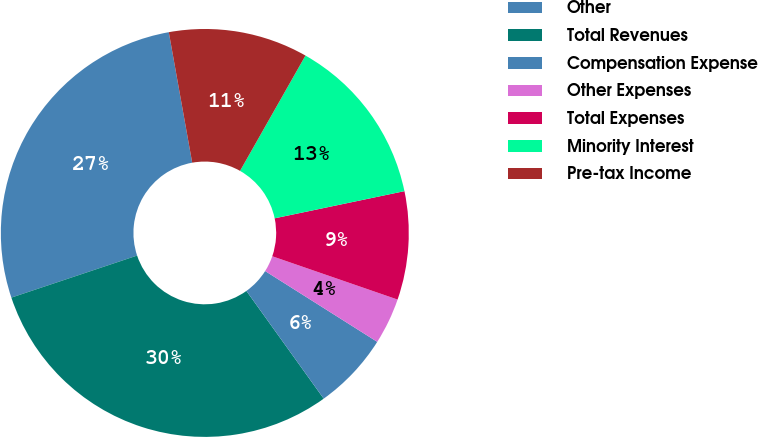Convert chart. <chart><loc_0><loc_0><loc_500><loc_500><pie_chart><fcel>Other<fcel>Total Revenues<fcel>Compensation Expense<fcel>Other Expenses<fcel>Total Expenses<fcel>Minority Interest<fcel>Pre-tax Income<nl><fcel>27.31%<fcel>29.77%<fcel>6.13%<fcel>3.67%<fcel>8.58%<fcel>13.5%<fcel>11.04%<nl></chart> 